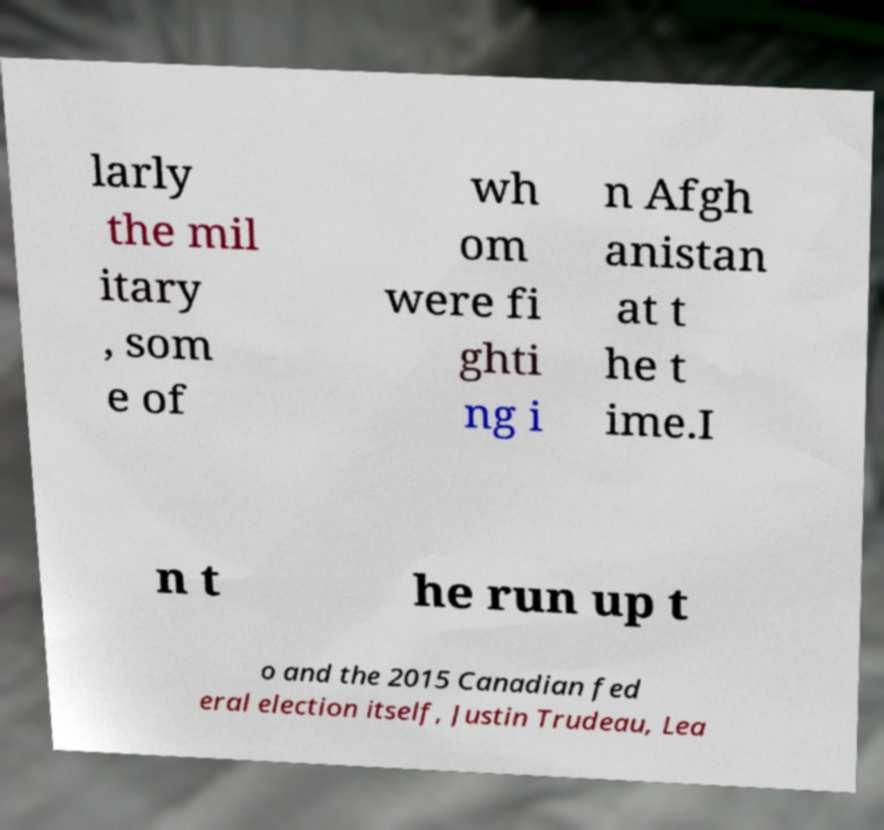What messages or text are displayed in this image? I need them in a readable, typed format. larly the mil itary , som e of wh om were fi ghti ng i n Afgh anistan at t he t ime.I n t he run up t o and the 2015 Canadian fed eral election itself, Justin Trudeau, Lea 